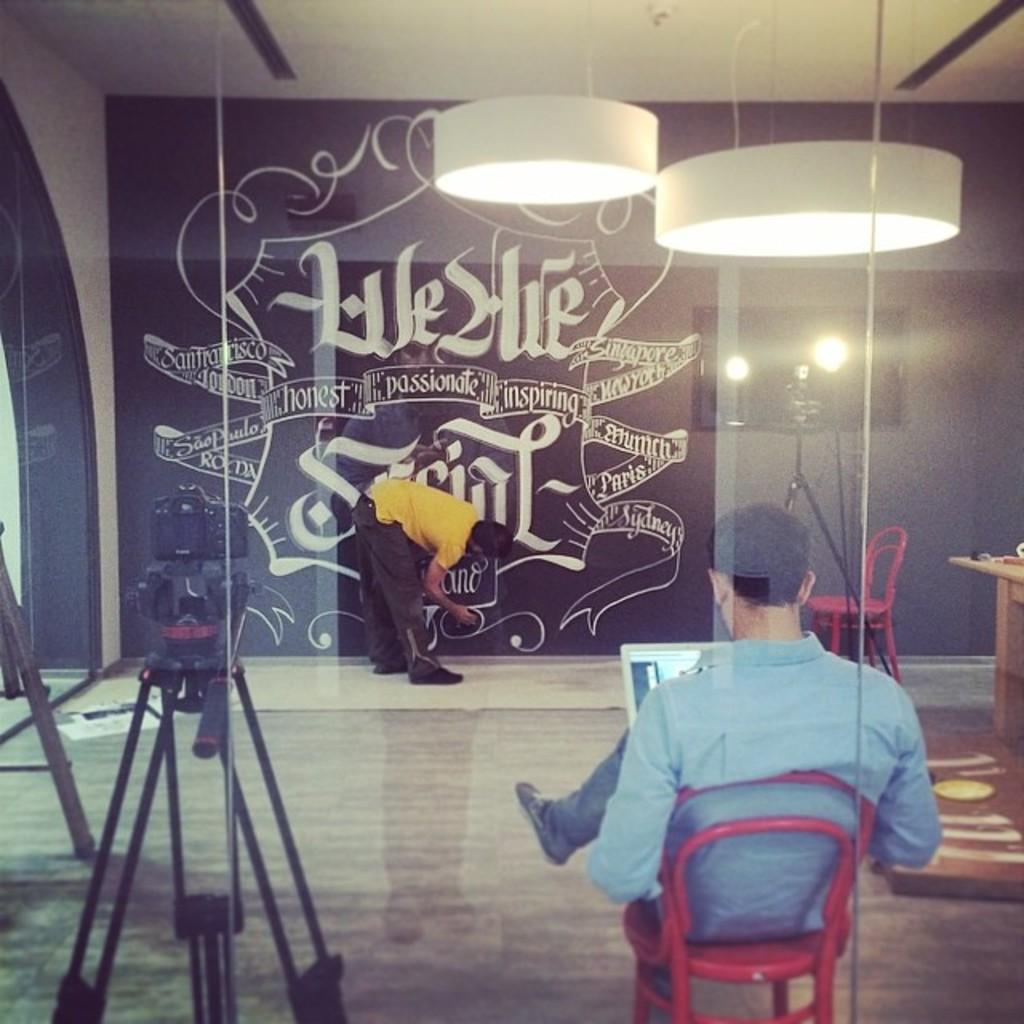What is the position of the first man in the image? There is a man sitting on a chair in the image. What is the position of the second man in the image? There is another man standing in the image. What can be seen in the image that provides illumination? There is a light in the image. What device is present in the image that is used for capturing images? There is a camera in the image. What type of crown is the man wearing in the image? There is no crown present in the image; the man is simply sitting on a chair. 